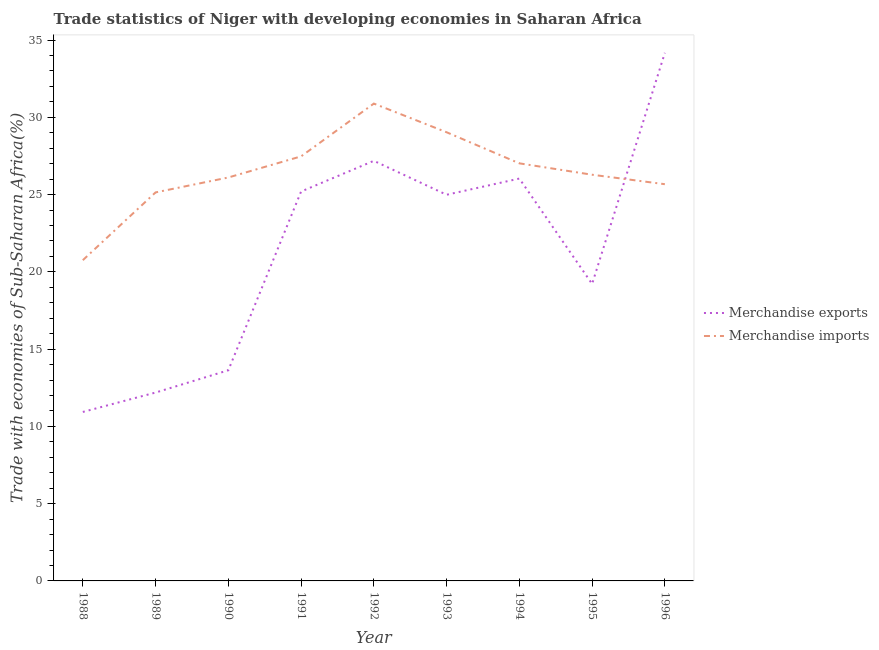Is the number of lines equal to the number of legend labels?
Keep it short and to the point. Yes. What is the merchandise exports in 1996?
Offer a very short reply. 34.17. Across all years, what is the maximum merchandise exports?
Keep it short and to the point. 34.17. Across all years, what is the minimum merchandise exports?
Your answer should be very brief. 10.93. In which year was the merchandise exports maximum?
Offer a very short reply. 1996. What is the total merchandise exports in the graph?
Keep it short and to the point. 193.56. What is the difference between the merchandise imports in 1988 and that in 1996?
Your answer should be very brief. -4.92. What is the difference between the merchandise imports in 1993 and the merchandise exports in 1992?
Make the answer very short. 1.85. What is the average merchandise imports per year?
Provide a short and direct response. 26.49. In the year 1993, what is the difference between the merchandise imports and merchandise exports?
Your answer should be compact. 4.04. What is the ratio of the merchandise exports in 1988 to that in 1995?
Offer a terse response. 0.57. Is the merchandise imports in 1990 less than that in 1994?
Offer a very short reply. Yes. What is the difference between the highest and the second highest merchandise exports?
Give a very brief answer. 6.99. What is the difference between the highest and the lowest merchandise exports?
Your response must be concise. 23.24. In how many years, is the merchandise exports greater than the average merchandise exports taken over all years?
Your response must be concise. 5. Is the sum of the merchandise exports in 1988 and 1990 greater than the maximum merchandise imports across all years?
Ensure brevity in your answer.  No. Does the graph contain grids?
Your answer should be very brief. No. Where does the legend appear in the graph?
Offer a terse response. Center right. How many legend labels are there?
Your answer should be very brief. 2. What is the title of the graph?
Make the answer very short. Trade statistics of Niger with developing economies in Saharan Africa. What is the label or title of the Y-axis?
Your answer should be compact. Trade with economies of Sub-Saharan Africa(%). What is the Trade with economies of Sub-Saharan Africa(%) of Merchandise exports in 1988?
Make the answer very short. 10.93. What is the Trade with economies of Sub-Saharan Africa(%) of Merchandise imports in 1988?
Ensure brevity in your answer.  20.76. What is the Trade with economies of Sub-Saharan Africa(%) of Merchandise exports in 1989?
Your response must be concise. 12.19. What is the Trade with economies of Sub-Saharan Africa(%) of Merchandise imports in 1989?
Keep it short and to the point. 25.14. What is the Trade with economies of Sub-Saharan Africa(%) in Merchandise exports in 1990?
Provide a succinct answer. 13.63. What is the Trade with economies of Sub-Saharan Africa(%) of Merchandise imports in 1990?
Provide a succinct answer. 26.11. What is the Trade with economies of Sub-Saharan Africa(%) in Merchandise exports in 1991?
Make the answer very short. 25.2. What is the Trade with economies of Sub-Saharan Africa(%) of Merchandise imports in 1991?
Your response must be concise. 27.47. What is the Trade with economies of Sub-Saharan Africa(%) in Merchandise exports in 1992?
Provide a succinct answer. 27.18. What is the Trade with economies of Sub-Saharan Africa(%) in Merchandise imports in 1992?
Keep it short and to the point. 30.89. What is the Trade with economies of Sub-Saharan Africa(%) in Merchandise exports in 1993?
Your answer should be compact. 24.99. What is the Trade with economies of Sub-Saharan Africa(%) of Merchandise imports in 1993?
Ensure brevity in your answer.  29.03. What is the Trade with economies of Sub-Saharan Africa(%) in Merchandise exports in 1994?
Offer a terse response. 26.04. What is the Trade with economies of Sub-Saharan Africa(%) in Merchandise imports in 1994?
Provide a succinct answer. 27.02. What is the Trade with economies of Sub-Saharan Africa(%) in Merchandise exports in 1995?
Keep it short and to the point. 19.22. What is the Trade with economies of Sub-Saharan Africa(%) of Merchandise imports in 1995?
Your answer should be compact. 26.29. What is the Trade with economies of Sub-Saharan Africa(%) of Merchandise exports in 1996?
Your response must be concise. 34.17. What is the Trade with economies of Sub-Saharan Africa(%) in Merchandise imports in 1996?
Provide a succinct answer. 25.67. Across all years, what is the maximum Trade with economies of Sub-Saharan Africa(%) in Merchandise exports?
Ensure brevity in your answer.  34.17. Across all years, what is the maximum Trade with economies of Sub-Saharan Africa(%) of Merchandise imports?
Your answer should be very brief. 30.89. Across all years, what is the minimum Trade with economies of Sub-Saharan Africa(%) in Merchandise exports?
Make the answer very short. 10.93. Across all years, what is the minimum Trade with economies of Sub-Saharan Africa(%) in Merchandise imports?
Make the answer very short. 20.76. What is the total Trade with economies of Sub-Saharan Africa(%) of Merchandise exports in the graph?
Give a very brief answer. 193.56. What is the total Trade with economies of Sub-Saharan Africa(%) in Merchandise imports in the graph?
Provide a short and direct response. 238.38. What is the difference between the Trade with economies of Sub-Saharan Africa(%) of Merchandise exports in 1988 and that in 1989?
Your response must be concise. -1.26. What is the difference between the Trade with economies of Sub-Saharan Africa(%) of Merchandise imports in 1988 and that in 1989?
Your answer should be very brief. -4.39. What is the difference between the Trade with economies of Sub-Saharan Africa(%) of Merchandise exports in 1988 and that in 1990?
Your answer should be compact. -2.7. What is the difference between the Trade with economies of Sub-Saharan Africa(%) in Merchandise imports in 1988 and that in 1990?
Provide a short and direct response. -5.35. What is the difference between the Trade with economies of Sub-Saharan Africa(%) in Merchandise exports in 1988 and that in 1991?
Provide a succinct answer. -14.26. What is the difference between the Trade with economies of Sub-Saharan Africa(%) of Merchandise imports in 1988 and that in 1991?
Your answer should be very brief. -6.72. What is the difference between the Trade with economies of Sub-Saharan Africa(%) of Merchandise exports in 1988 and that in 1992?
Offer a very short reply. -16.25. What is the difference between the Trade with economies of Sub-Saharan Africa(%) in Merchandise imports in 1988 and that in 1992?
Keep it short and to the point. -10.13. What is the difference between the Trade with economies of Sub-Saharan Africa(%) of Merchandise exports in 1988 and that in 1993?
Provide a short and direct response. -14.05. What is the difference between the Trade with economies of Sub-Saharan Africa(%) in Merchandise imports in 1988 and that in 1993?
Your answer should be very brief. -8.28. What is the difference between the Trade with economies of Sub-Saharan Africa(%) of Merchandise exports in 1988 and that in 1994?
Provide a short and direct response. -15.1. What is the difference between the Trade with economies of Sub-Saharan Africa(%) in Merchandise imports in 1988 and that in 1994?
Your response must be concise. -6.27. What is the difference between the Trade with economies of Sub-Saharan Africa(%) in Merchandise exports in 1988 and that in 1995?
Your answer should be compact. -8.28. What is the difference between the Trade with economies of Sub-Saharan Africa(%) in Merchandise imports in 1988 and that in 1995?
Your answer should be very brief. -5.53. What is the difference between the Trade with economies of Sub-Saharan Africa(%) of Merchandise exports in 1988 and that in 1996?
Offer a very short reply. -23.24. What is the difference between the Trade with economies of Sub-Saharan Africa(%) in Merchandise imports in 1988 and that in 1996?
Your response must be concise. -4.92. What is the difference between the Trade with economies of Sub-Saharan Africa(%) in Merchandise exports in 1989 and that in 1990?
Your answer should be very brief. -1.44. What is the difference between the Trade with economies of Sub-Saharan Africa(%) of Merchandise imports in 1989 and that in 1990?
Your response must be concise. -0.96. What is the difference between the Trade with economies of Sub-Saharan Africa(%) of Merchandise exports in 1989 and that in 1991?
Provide a succinct answer. -13.01. What is the difference between the Trade with economies of Sub-Saharan Africa(%) in Merchandise imports in 1989 and that in 1991?
Provide a short and direct response. -2.33. What is the difference between the Trade with economies of Sub-Saharan Africa(%) of Merchandise exports in 1989 and that in 1992?
Ensure brevity in your answer.  -14.99. What is the difference between the Trade with economies of Sub-Saharan Africa(%) of Merchandise imports in 1989 and that in 1992?
Ensure brevity in your answer.  -5.75. What is the difference between the Trade with economies of Sub-Saharan Africa(%) in Merchandise exports in 1989 and that in 1993?
Ensure brevity in your answer.  -12.8. What is the difference between the Trade with economies of Sub-Saharan Africa(%) in Merchandise imports in 1989 and that in 1993?
Keep it short and to the point. -3.89. What is the difference between the Trade with economies of Sub-Saharan Africa(%) in Merchandise exports in 1989 and that in 1994?
Keep it short and to the point. -13.85. What is the difference between the Trade with economies of Sub-Saharan Africa(%) of Merchandise imports in 1989 and that in 1994?
Ensure brevity in your answer.  -1.88. What is the difference between the Trade with economies of Sub-Saharan Africa(%) of Merchandise exports in 1989 and that in 1995?
Provide a short and direct response. -7.03. What is the difference between the Trade with economies of Sub-Saharan Africa(%) in Merchandise imports in 1989 and that in 1995?
Offer a very short reply. -1.14. What is the difference between the Trade with economies of Sub-Saharan Africa(%) of Merchandise exports in 1989 and that in 1996?
Ensure brevity in your answer.  -21.98. What is the difference between the Trade with economies of Sub-Saharan Africa(%) of Merchandise imports in 1989 and that in 1996?
Your response must be concise. -0.53. What is the difference between the Trade with economies of Sub-Saharan Africa(%) of Merchandise exports in 1990 and that in 1991?
Give a very brief answer. -11.57. What is the difference between the Trade with economies of Sub-Saharan Africa(%) of Merchandise imports in 1990 and that in 1991?
Provide a short and direct response. -1.37. What is the difference between the Trade with economies of Sub-Saharan Africa(%) in Merchandise exports in 1990 and that in 1992?
Ensure brevity in your answer.  -13.55. What is the difference between the Trade with economies of Sub-Saharan Africa(%) of Merchandise imports in 1990 and that in 1992?
Your answer should be compact. -4.78. What is the difference between the Trade with economies of Sub-Saharan Africa(%) in Merchandise exports in 1990 and that in 1993?
Provide a succinct answer. -11.36. What is the difference between the Trade with economies of Sub-Saharan Africa(%) of Merchandise imports in 1990 and that in 1993?
Offer a terse response. -2.93. What is the difference between the Trade with economies of Sub-Saharan Africa(%) in Merchandise exports in 1990 and that in 1994?
Offer a terse response. -12.41. What is the difference between the Trade with economies of Sub-Saharan Africa(%) of Merchandise imports in 1990 and that in 1994?
Offer a very short reply. -0.92. What is the difference between the Trade with economies of Sub-Saharan Africa(%) in Merchandise exports in 1990 and that in 1995?
Make the answer very short. -5.58. What is the difference between the Trade with economies of Sub-Saharan Africa(%) of Merchandise imports in 1990 and that in 1995?
Provide a succinct answer. -0.18. What is the difference between the Trade with economies of Sub-Saharan Africa(%) of Merchandise exports in 1990 and that in 1996?
Keep it short and to the point. -20.54. What is the difference between the Trade with economies of Sub-Saharan Africa(%) in Merchandise imports in 1990 and that in 1996?
Offer a very short reply. 0.43. What is the difference between the Trade with economies of Sub-Saharan Africa(%) in Merchandise exports in 1991 and that in 1992?
Your response must be concise. -1.99. What is the difference between the Trade with economies of Sub-Saharan Africa(%) in Merchandise imports in 1991 and that in 1992?
Make the answer very short. -3.42. What is the difference between the Trade with economies of Sub-Saharan Africa(%) of Merchandise exports in 1991 and that in 1993?
Offer a very short reply. 0.21. What is the difference between the Trade with economies of Sub-Saharan Africa(%) in Merchandise imports in 1991 and that in 1993?
Provide a succinct answer. -1.56. What is the difference between the Trade with economies of Sub-Saharan Africa(%) in Merchandise exports in 1991 and that in 1994?
Ensure brevity in your answer.  -0.84. What is the difference between the Trade with economies of Sub-Saharan Africa(%) of Merchandise imports in 1991 and that in 1994?
Make the answer very short. 0.45. What is the difference between the Trade with economies of Sub-Saharan Africa(%) in Merchandise exports in 1991 and that in 1995?
Your answer should be compact. 5.98. What is the difference between the Trade with economies of Sub-Saharan Africa(%) of Merchandise imports in 1991 and that in 1995?
Provide a succinct answer. 1.19. What is the difference between the Trade with economies of Sub-Saharan Africa(%) in Merchandise exports in 1991 and that in 1996?
Ensure brevity in your answer.  -8.97. What is the difference between the Trade with economies of Sub-Saharan Africa(%) in Merchandise imports in 1991 and that in 1996?
Offer a very short reply. 1.8. What is the difference between the Trade with economies of Sub-Saharan Africa(%) of Merchandise exports in 1992 and that in 1993?
Give a very brief answer. 2.2. What is the difference between the Trade with economies of Sub-Saharan Africa(%) in Merchandise imports in 1992 and that in 1993?
Your response must be concise. 1.85. What is the difference between the Trade with economies of Sub-Saharan Africa(%) of Merchandise exports in 1992 and that in 1994?
Offer a terse response. 1.15. What is the difference between the Trade with economies of Sub-Saharan Africa(%) in Merchandise imports in 1992 and that in 1994?
Your answer should be very brief. 3.87. What is the difference between the Trade with economies of Sub-Saharan Africa(%) of Merchandise exports in 1992 and that in 1995?
Provide a succinct answer. 7.97. What is the difference between the Trade with economies of Sub-Saharan Africa(%) of Merchandise imports in 1992 and that in 1995?
Give a very brief answer. 4.6. What is the difference between the Trade with economies of Sub-Saharan Africa(%) in Merchandise exports in 1992 and that in 1996?
Offer a very short reply. -6.99. What is the difference between the Trade with economies of Sub-Saharan Africa(%) of Merchandise imports in 1992 and that in 1996?
Offer a very short reply. 5.22. What is the difference between the Trade with economies of Sub-Saharan Africa(%) in Merchandise exports in 1993 and that in 1994?
Ensure brevity in your answer.  -1.05. What is the difference between the Trade with economies of Sub-Saharan Africa(%) of Merchandise imports in 1993 and that in 1994?
Ensure brevity in your answer.  2.01. What is the difference between the Trade with economies of Sub-Saharan Africa(%) in Merchandise exports in 1993 and that in 1995?
Provide a succinct answer. 5.77. What is the difference between the Trade with economies of Sub-Saharan Africa(%) in Merchandise imports in 1993 and that in 1995?
Make the answer very short. 2.75. What is the difference between the Trade with economies of Sub-Saharan Africa(%) in Merchandise exports in 1993 and that in 1996?
Ensure brevity in your answer.  -9.18. What is the difference between the Trade with economies of Sub-Saharan Africa(%) of Merchandise imports in 1993 and that in 1996?
Your answer should be compact. 3.36. What is the difference between the Trade with economies of Sub-Saharan Africa(%) in Merchandise exports in 1994 and that in 1995?
Give a very brief answer. 6.82. What is the difference between the Trade with economies of Sub-Saharan Africa(%) in Merchandise imports in 1994 and that in 1995?
Ensure brevity in your answer.  0.74. What is the difference between the Trade with economies of Sub-Saharan Africa(%) in Merchandise exports in 1994 and that in 1996?
Offer a very short reply. -8.14. What is the difference between the Trade with economies of Sub-Saharan Africa(%) of Merchandise imports in 1994 and that in 1996?
Keep it short and to the point. 1.35. What is the difference between the Trade with economies of Sub-Saharan Africa(%) of Merchandise exports in 1995 and that in 1996?
Ensure brevity in your answer.  -14.96. What is the difference between the Trade with economies of Sub-Saharan Africa(%) of Merchandise imports in 1995 and that in 1996?
Make the answer very short. 0.61. What is the difference between the Trade with economies of Sub-Saharan Africa(%) in Merchandise exports in 1988 and the Trade with economies of Sub-Saharan Africa(%) in Merchandise imports in 1989?
Provide a short and direct response. -14.21. What is the difference between the Trade with economies of Sub-Saharan Africa(%) in Merchandise exports in 1988 and the Trade with economies of Sub-Saharan Africa(%) in Merchandise imports in 1990?
Your answer should be very brief. -15.17. What is the difference between the Trade with economies of Sub-Saharan Africa(%) of Merchandise exports in 1988 and the Trade with economies of Sub-Saharan Africa(%) of Merchandise imports in 1991?
Offer a terse response. -16.54. What is the difference between the Trade with economies of Sub-Saharan Africa(%) in Merchandise exports in 1988 and the Trade with economies of Sub-Saharan Africa(%) in Merchandise imports in 1992?
Your answer should be compact. -19.95. What is the difference between the Trade with economies of Sub-Saharan Africa(%) in Merchandise exports in 1988 and the Trade with economies of Sub-Saharan Africa(%) in Merchandise imports in 1993?
Give a very brief answer. -18.1. What is the difference between the Trade with economies of Sub-Saharan Africa(%) in Merchandise exports in 1988 and the Trade with economies of Sub-Saharan Africa(%) in Merchandise imports in 1994?
Provide a succinct answer. -16.09. What is the difference between the Trade with economies of Sub-Saharan Africa(%) of Merchandise exports in 1988 and the Trade with economies of Sub-Saharan Africa(%) of Merchandise imports in 1995?
Your answer should be compact. -15.35. What is the difference between the Trade with economies of Sub-Saharan Africa(%) in Merchandise exports in 1988 and the Trade with economies of Sub-Saharan Africa(%) in Merchandise imports in 1996?
Ensure brevity in your answer.  -14.74. What is the difference between the Trade with economies of Sub-Saharan Africa(%) in Merchandise exports in 1989 and the Trade with economies of Sub-Saharan Africa(%) in Merchandise imports in 1990?
Keep it short and to the point. -13.92. What is the difference between the Trade with economies of Sub-Saharan Africa(%) in Merchandise exports in 1989 and the Trade with economies of Sub-Saharan Africa(%) in Merchandise imports in 1991?
Provide a short and direct response. -15.28. What is the difference between the Trade with economies of Sub-Saharan Africa(%) in Merchandise exports in 1989 and the Trade with economies of Sub-Saharan Africa(%) in Merchandise imports in 1992?
Provide a succinct answer. -18.7. What is the difference between the Trade with economies of Sub-Saharan Africa(%) of Merchandise exports in 1989 and the Trade with economies of Sub-Saharan Africa(%) of Merchandise imports in 1993?
Keep it short and to the point. -16.84. What is the difference between the Trade with economies of Sub-Saharan Africa(%) of Merchandise exports in 1989 and the Trade with economies of Sub-Saharan Africa(%) of Merchandise imports in 1994?
Ensure brevity in your answer.  -14.83. What is the difference between the Trade with economies of Sub-Saharan Africa(%) in Merchandise exports in 1989 and the Trade with economies of Sub-Saharan Africa(%) in Merchandise imports in 1995?
Provide a short and direct response. -14.1. What is the difference between the Trade with economies of Sub-Saharan Africa(%) of Merchandise exports in 1989 and the Trade with economies of Sub-Saharan Africa(%) of Merchandise imports in 1996?
Your answer should be very brief. -13.48. What is the difference between the Trade with economies of Sub-Saharan Africa(%) in Merchandise exports in 1990 and the Trade with economies of Sub-Saharan Africa(%) in Merchandise imports in 1991?
Ensure brevity in your answer.  -13.84. What is the difference between the Trade with economies of Sub-Saharan Africa(%) of Merchandise exports in 1990 and the Trade with economies of Sub-Saharan Africa(%) of Merchandise imports in 1992?
Ensure brevity in your answer.  -17.26. What is the difference between the Trade with economies of Sub-Saharan Africa(%) in Merchandise exports in 1990 and the Trade with economies of Sub-Saharan Africa(%) in Merchandise imports in 1993?
Give a very brief answer. -15.4. What is the difference between the Trade with economies of Sub-Saharan Africa(%) in Merchandise exports in 1990 and the Trade with economies of Sub-Saharan Africa(%) in Merchandise imports in 1994?
Keep it short and to the point. -13.39. What is the difference between the Trade with economies of Sub-Saharan Africa(%) of Merchandise exports in 1990 and the Trade with economies of Sub-Saharan Africa(%) of Merchandise imports in 1995?
Your answer should be very brief. -12.65. What is the difference between the Trade with economies of Sub-Saharan Africa(%) of Merchandise exports in 1990 and the Trade with economies of Sub-Saharan Africa(%) of Merchandise imports in 1996?
Offer a very short reply. -12.04. What is the difference between the Trade with economies of Sub-Saharan Africa(%) of Merchandise exports in 1991 and the Trade with economies of Sub-Saharan Africa(%) of Merchandise imports in 1992?
Offer a very short reply. -5.69. What is the difference between the Trade with economies of Sub-Saharan Africa(%) in Merchandise exports in 1991 and the Trade with economies of Sub-Saharan Africa(%) in Merchandise imports in 1993?
Make the answer very short. -3.84. What is the difference between the Trade with economies of Sub-Saharan Africa(%) in Merchandise exports in 1991 and the Trade with economies of Sub-Saharan Africa(%) in Merchandise imports in 1994?
Your answer should be very brief. -1.82. What is the difference between the Trade with economies of Sub-Saharan Africa(%) of Merchandise exports in 1991 and the Trade with economies of Sub-Saharan Africa(%) of Merchandise imports in 1995?
Your response must be concise. -1.09. What is the difference between the Trade with economies of Sub-Saharan Africa(%) in Merchandise exports in 1991 and the Trade with economies of Sub-Saharan Africa(%) in Merchandise imports in 1996?
Ensure brevity in your answer.  -0.47. What is the difference between the Trade with economies of Sub-Saharan Africa(%) of Merchandise exports in 1992 and the Trade with economies of Sub-Saharan Africa(%) of Merchandise imports in 1993?
Provide a succinct answer. -1.85. What is the difference between the Trade with economies of Sub-Saharan Africa(%) in Merchandise exports in 1992 and the Trade with economies of Sub-Saharan Africa(%) in Merchandise imports in 1994?
Your response must be concise. 0.16. What is the difference between the Trade with economies of Sub-Saharan Africa(%) of Merchandise exports in 1992 and the Trade with economies of Sub-Saharan Africa(%) of Merchandise imports in 1995?
Your response must be concise. 0.9. What is the difference between the Trade with economies of Sub-Saharan Africa(%) of Merchandise exports in 1992 and the Trade with economies of Sub-Saharan Africa(%) of Merchandise imports in 1996?
Make the answer very short. 1.51. What is the difference between the Trade with economies of Sub-Saharan Africa(%) in Merchandise exports in 1993 and the Trade with economies of Sub-Saharan Africa(%) in Merchandise imports in 1994?
Offer a terse response. -2.03. What is the difference between the Trade with economies of Sub-Saharan Africa(%) of Merchandise exports in 1993 and the Trade with economies of Sub-Saharan Africa(%) of Merchandise imports in 1995?
Provide a succinct answer. -1.3. What is the difference between the Trade with economies of Sub-Saharan Africa(%) in Merchandise exports in 1993 and the Trade with economies of Sub-Saharan Africa(%) in Merchandise imports in 1996?
Your answer should be very brief. -0.68. What is the difference between the Trade with economies of Sub-Saharan Africa(%) of Merchandise exports in 1994 and the Trade with economies of Sub-Saharan Africa(%) of Merchandise imports in 1995?
Provide a succinct answer. -0.25. What is the difference between the Trade with economies of Sub-Saharan Africa(%) in Merchandise exports in 1994 and the Trade with economies of Sub-Saharan Africa(%) in Merchandise imports in 1996?
Provide a short and direct response. 0.36. What is the difference between the Trade with economies of Sub-Saharan Africa(%) of Merchandise exports in 1995 and the Trade with economies of Sub-Saharan Africa(%) of Merchandise imports in 1996?
Ensure brevity in your answer.  -6.46. What is the average Trade with economies of Sub-Saharan Africa(%) of Merchandise exports per year?
Offer a terse response. 21.51. What is the average Trade with economies of Sub-Saharan Africa(%) in Merchandise imports per year?
Offer a terse response. 26.49. In the year 1988, what is the difference between the Trade with economies of Sub-Saharan Africa(%) of Merchandise exports and Trade with economies of Sub-Saharan Africa(%) of Merchandise imports?
Give a very brief answer. -9.82. In the year 1989, what is the difference between the Trade with economies of Sub-Saharan Africa(%) in Merchandise exports and Trade with economies of Sub-Saharan Africa(%) in Merchandise imports?
Your answer should be very brief. -12.95. In the year 1990, what is the difference between the Trade with economies of Sub-Saharan Africa(%) of Merchandise exports and Trade with economies of Sub-Saharan Africa(%) of Merchandise imports?
Your answer should be compact. -12.47. In the year 1991, what is the difference between the Trade with economies of Sub-Saharan Africa(%) in Merchandise exports and Trade with economies of Sub-Saharan Africa(%) in Merchandise imports?
Provide a short and direct response. -2.27. In the year 1992, what is the difference between the Trade with economies of Sub-Saharan Africa(%) in Merchandise exports and Trade with economies of Sub-Saharan Africa(%) in Merchandise imports?
Give a very brief answer. -3.7. In the year 1993, what is the difference between the Trade with economies of Sub-Saharan Africa(%) of Merchandise exports and Trade with economies of Sub-Saharan Africa(%) of Merchandise imports?
Ensure brevity in your answer.  -4.04. In the year 1994, what is the difference between the Trade with economies of Sub-Saharan Africa(%) of Merchandise exports and Trade with economies of Sub-Saharan Africa(%) of Merchandise imports?
Provide a succinct answer. -0.98. In the year 1995, what is the difference between the Trade with economies of Sub-Saharan Africa(%) in Merchandise exports and Trade with economies of Sub-Saharan Africa(%) in Merchandise imports?
Offer a very short reply. -7.07. In the year 1996, what is the difference between the Trade with economies of Sub-Saharan Africa(%) in Merchandise exports and Trade with economies of Sub-Saharan Africa(%) in Merchandise imports?
Keep it short and to the point. 8.5. What is the ratio of the Trade with economies of Sub-Saharan Africa(%) of Merchandise exports in 1988 to that in 1989?
Provide a short and direct response. 0.9. What is the ratio of the Trade with economies of Sub-Saharan Africa(%) in Merchandise imports in 1988 to that in 1989?
Make the answer very short. 0.83. What is the ratio of the Trade with economies of Sub-Saharan Africa(%) in Merchandise exports in 1988 to that in 1990?
Offer a terse response. 0.8. What is the ratio of the Trade with economies of Sub-Saharan Africa(%) in Merchandise imports in 1988 to that in 1990?
Make the answer very short. 0.8. What is the ratio of the Trade with economies of Sub-Saharan Africa(%) of Merchandise exports in 1988 to that in 1991?
Offer a terse response. 0.43. What is the ratio of the Trade with economies of Sub-Saharan Africa(%) in Merchandise imports in 1988 to that in 1991?
Keep it short and to the point. 0.76. What is the ratio of the Trade with economies of Sub-Saharan Africa(%) in Merchandise exports in 1988 to that in 1992?
Provide a succinct answer. 0.4. What is the ratio of the Trade with economies of Sub-Saharan Africa(%) of Merchandise imports in 1988 to that in 1992?
Provide a short and direct response. 0.67. What is the ratio of the Trade with economies of Sub-Saharan Africa(%) in Merchandise exports in 1988 to that in 1993?
Make the answer very short. 0.44. What is the ratio of the Trade with economies of Sub-Saharan Africa(%) of Merchandise imports in 1988 to that in 1993?
Ensure brevity in your answer.  0.71. What is the ratio of the Trade with economies of Sub-Saharan Africa(%) of Merchandise exports in 1988 to that in 1994?
Provide a succinct answer. 0.42. What is the ratio of the Trade with economies of Sub-Saharan Africa(%) of Merchandise imports in 1988 to that in 1994?
Provide a succinct answer. 0.77. What is the ratio of the Trade with economies of Sub-Saharan Africa(%) of Merchandise exports in 1988 to that in 1995?
Give a very brief answer. 0.57. What is the ratio of the Trade with economies of Sub-Saharan Africa(%) of Merchandise imports in 1988 to that in 1995?
Keep it short and to the point. 0.79. What is the ratio of the Trade with economies of Sub-Saharan Africa(%) in Merchandise exports in 1988 to that in 1996?
Your answer should be compact. 0.32. What is the ratio of the Trade with economies of Sub-Saharan Africa(%) of Merchandise imports in 1988 to that in 1996?
Provide a short and direct response. 0.81. What is the ratio of the Trade with economies of Sub-Saharan Africa(%) of Merchandise exports in 1989 to that in 1990?
Provide a short and direct response. 0.89. What is the ratio of the Trade with economies of Sub-Saharan Africa(%) of Merchandise imports in 1989 to that in 1990?
Make the answer very short. 0.96. What is the ratio of the Trade with economies of Sub-Saharan Africa(%) in Merchandise exports in 1989 to that in 1991?
Your answer should be compact. 0.48. What is the ratio of the Trade with economies of Sub-Saharan Africa(%) of Merchandise imports in 1989 to that in 1991?
Offer a terse response. 0.92. What is the ratio of the Trade with economies of Sub-Saharan Africa(%) in Merchandise exports in 1989 to that in 1992?
Offer a terse response. 0.45. What is the ratio of the Trade with economies of Sub-Saharan Africa(%) in Merchandise imports in 1989 to that in 1992?
Your answer should be very brief. 0.81. What is the ratio of the Trade with economies of Sub-Saharan Africa(%) in Merchandise exports in 1989 to that in 1993?
Provide a short and direct response. 0.49. What is the ratio of the Trade with economies of Sub-Saharan Africa(%) of Merchandise imports in 1989 to that in 1993?
Ensure brevity in your answer.  0.87. What is the ratio of the Trade with economies of Sub-Saharan Africa(%) in Merchandise exports in 1989 to that in 1994?
Your response must be concise. 0.47. What is the ratio of the Trade with economies of Sub-Saharan Africa(%) of Merchandise imports in 1989 to that in 1994?
Offer a very short reply. 0.93. What is the ratio of the Trade with economies of Sub-Saharan Africa(%) in Merchandise exports in 1989 to that in 1995?
Give a very brief answer. 0.63. What is the ratio of the Trade with economies of Sub-Saharan Africa(%) in Merchandise imports in 1989 to that in 1995?
Your response must be concise. 0.96. What is the ratio of the Trade with economies of Sub-Saharan Africa(%) in Merchandise exports in 1989 to that in 1996?
Provide a short and direct response. 0.36. What is the ratio of the Trade with economies of Sub-Saharan Africa(%) of Merchandise imports in 1989 to that in 1996?
Offer a terse response. 0.98. What is the ratio of the Trade with economies of Sub-Saharan Africa(%) in Merchandise exports in 1990 to that in 1991?
Ensure brevity in your answer.  0.54. What is the ratio of the Trade with economies of Sub-Saharan Africa(%) of Merchandise imports in 1990 to that in 1991?
Provide a succinct answer. 0.95. What is the ratio of the Trade with economies of Sub-Saharan Africa(%) of Merchandise exports in 1990 to that in 1992?
Offer a terse response. 0.5. What is the ratio of the Trade with economies of Sub-Saharan Africa(%) in Merchandise imports in 1990 to that in 1992?
Your answer should be very brief. 0.85. What is the ratio of the Trade with economies of Sub-Saharan Africa(%) in Merchandise exports in 1990 to that in 1993?
Provide a succinct answer. 0.55. What is the ratio of the Trade with economies of Sub-Saharan Africa(%) in Merchandise imports in 1990 to that in 1993?
Make the answer very short. 0.9. What is the ratio of the Trade with economies of Sub-Saharan Africa(%) in Merchandise exports in 1990 to that in 1994?
Your answer should be compact. 0.52. What is the ratio of the Trade with economies of Sub-Saharan Africa(%) of Merchandise imports in 1990 to that in 1994?
Your answer should be compact. 0.97. What is the ratio of the Trade with economies of Sub-Saharan Africa(%) of Merchandise exports in 1990 to that in 1995?
Make the answer very short. 0.71. What is the ratio of the Trade with economies of Sub-Saharan Africa(%) in Merchandise exports in 1990 to that in 1996?
Offer a very short reply. 0.4. What is the ratio of the Trade with economies of Sub-Saharan Africa(%) in Merchandise imports in 1990 to that in 1996?
Make the answer very short. 1.02. What is the ratio of the Trade with economies of Sub-Saharan Africa(%) of Merchandise exports in 1991 to that in 1992?
Provide a short and direct response. 0.93. What is the ratio of the Trade with economies of Sub-Saharan Africa(%) of Merchandise imports in 1991 to that in 1992?
Your answer should be compact. 0.89. What is the ratio of the Trade with economies of Sub-Saharan Africa(%) in Merchandise exports in 1991 to that in 1993?
Your answer should be very brief. 1.01. What is the ratio of the Trade with economies of Sub-Saharan Africa(%) in Merchandise imports in 1991 to that in 1993?
Offer a very short reply. 0.95. What is the ratio of the Trade with economies of Sub-Saharan Africa(%) of Merchandise exports in 1991 to that in 1994?
Provide a short and direct response. 0.97. What is the ratio of the Trade with economies of Sub-Saharan Africa(%) of Merchandise imports in 1991 to that in 1994?
Your response must be concise. 1.02. What is the ratio of the Trade with economies of Sub-Saharan Africa(%) of Merchandise exports in 1991 to that in 1995?
Make the answer very short. 1.31. What is the ratio of the Trade with economies of Sub-Saharan Africa(%) of Merchandise imports in 1991 to that in 1995?
Ensure brevity in your answer.  1.05. What is the ratio of the Trade with economies of Sub-Saharan Africa(%) of Merchandise exports in 1991 to that in 1996?
Provide a short and direct response. 0.74. What is the ratio of the Trade with economies of Sub-Saharan Africa(%) of Merchandise imports in 1991 to that in 1996?
Your answer should be very brief. 1.07. What is the ratio of the Trade with economies of Sub-Saharan Africa(%) in Merchandise exports in 1992 to that in 1993?
Keep it short and to the point. 1.09. What is the ratio of the Trade with economies of Sub-Saharan Africa(%) of Merchandise imports in 1992 to that in 1993?
Provide a short and direct response. 1.06. What is the ratio of the Trade with economies of Sub-Saharan Africa(%) of Merchandise exports in 1992 to that in 1994?
Give a very brief answer. 1.04. What is the ratio of the Trade with economies of Sub-Saharan Africa(%) of Merchandise imports in 1992 to that in 1994?
Provide a succinct answer. 1.14. What is the ratio of the Trade with economies of Sub-Saharan Africa(%) in Merchandise exports in 1992 to that in 1995?
Provide a short and direct response. 1.41. What is the ratio of the Trade with economies of Sub-Saharan Africa(%) of Merchandise imports in 1992 to that in 1995?
Provide a short and direct response. 1.18. What is the ratio of the Trade with economies of Sub-Saharan Africa(%) of Merchandise exports in 1992 to that in 1996?
Provide a succinct answer. 0.8. What is the ratio of the Trade with economies of Sub-Saharan Africa(%) in Merchandise imports in 1992 to that in 1996?
Offer a terse response. 1.2. What is the ratio of the Trade with economies of Sub-Saharan Africa(%) of Merchandise exports in 1993 to that in 1994?
Offer a terse response. 0.96. What is the ratio of the Trade with economies of Sub-Saharan Africa(%) of Merchandise imports in 1993 to that in 1994?
Offer a terse response. 1.07. What is the ratio of the Trade with economies of Sub-Saharan Africa(%) in Merchandise exports in 1993 to that in 1995?
Make the answer very short. 1.3. What is the ratio of the Trade with economies of Sub-Saharan Africa(%) of Merchandise imports in 1993 to that in 1995?
Offer a very short reply. 1.1. What is the ratio of the Trade with economies of Sub-Saharan Africa(%) in Merchandise exports in 1993 to that in 1996?
Your answer should be compact. 0.73. What is the ratio of the Trade with economies of Sub-Saharan Africa(%) of Merchandise imports in 1993 to that in 1996?
Offer a very short reply. 1.13. What is the ratio of the Trade with economies of Sub-Saharan Africa(%) in Merchandise exports in 1994 to that in 1995?
Make the answer very short. 1.35. What is the ratio of the Trade with economies of Sub-Saharan Africa(%) in Merchandise imports in 1994 to that in 1995?
Ensure brevity in your answer.  1.03. What is the ratio of the Trade with economies of Sub-Saharan Africa(%) of Merchandise exports in 1994 to that in 1996?
Give a very brief answer. 0.76. What is the ratio of the Trade with economies of Sub-Saharan Africa(%) in Merchandise imports in 1994 to that in 1996?
Provide a short and direct response. 1.05. What is the ratio of the Trade with economies of Sub-Saharan Africa(%) in Merchandise exports in 1995 to that in 1996?
Give a very brief answer. 0.56. What is the ratio of the Trade with economies of Sub-Saharan Africa(%) in Merchandise imports in 1995 to that in 1996?
Offer a terse response. 1.02. What is the difference between the highest and the second highest Trade with economies of Sub-Saharan Africa(%) in Merchandise exports?
Offer a terse response. 6.99. What is the difference between the highest and the second highest Trade with economies of Sub-Saharan Africa(%) of Merchandise imports?
Your answer should be very brief. 1.85. What is the difference between the highest and the lowest Trade with economies of Sub-Saharan Africa(%) of Merchandise exports?
Keep it short and to the point. 23.24. What is the difference between the highest and the lowest Trade with economies of Sub-Saharan Africa(%) in Merchandise imports?
Your answer should be compact. 10.13. 